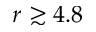Convert formula to latex. <formula><loc_0><loc_0><loc_500><loc_500>r \gtrsim 4 . 8</formula> 